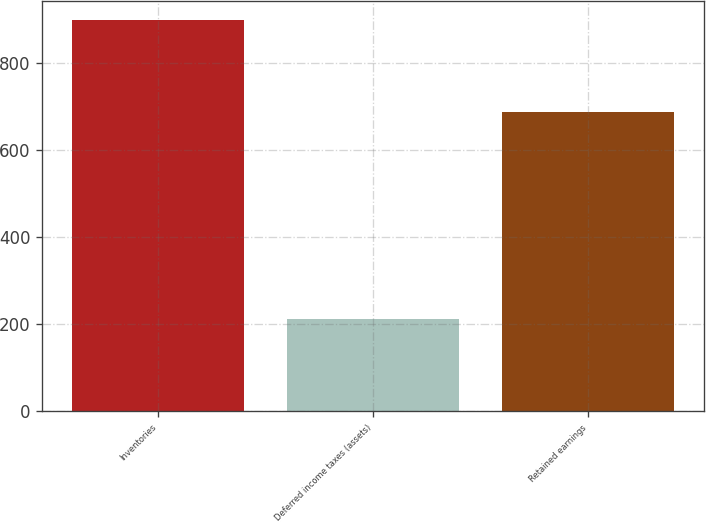Convert chart to OTSL. <chart><loc_0><loc_0><loc_500><loc_500><bar_chart><fcel>Inventories<fcel>Deferred income taxes (assets)<fcel>Retained earnings<nl><fcel>899<fcel>211<fcel>688<nl></chart> 